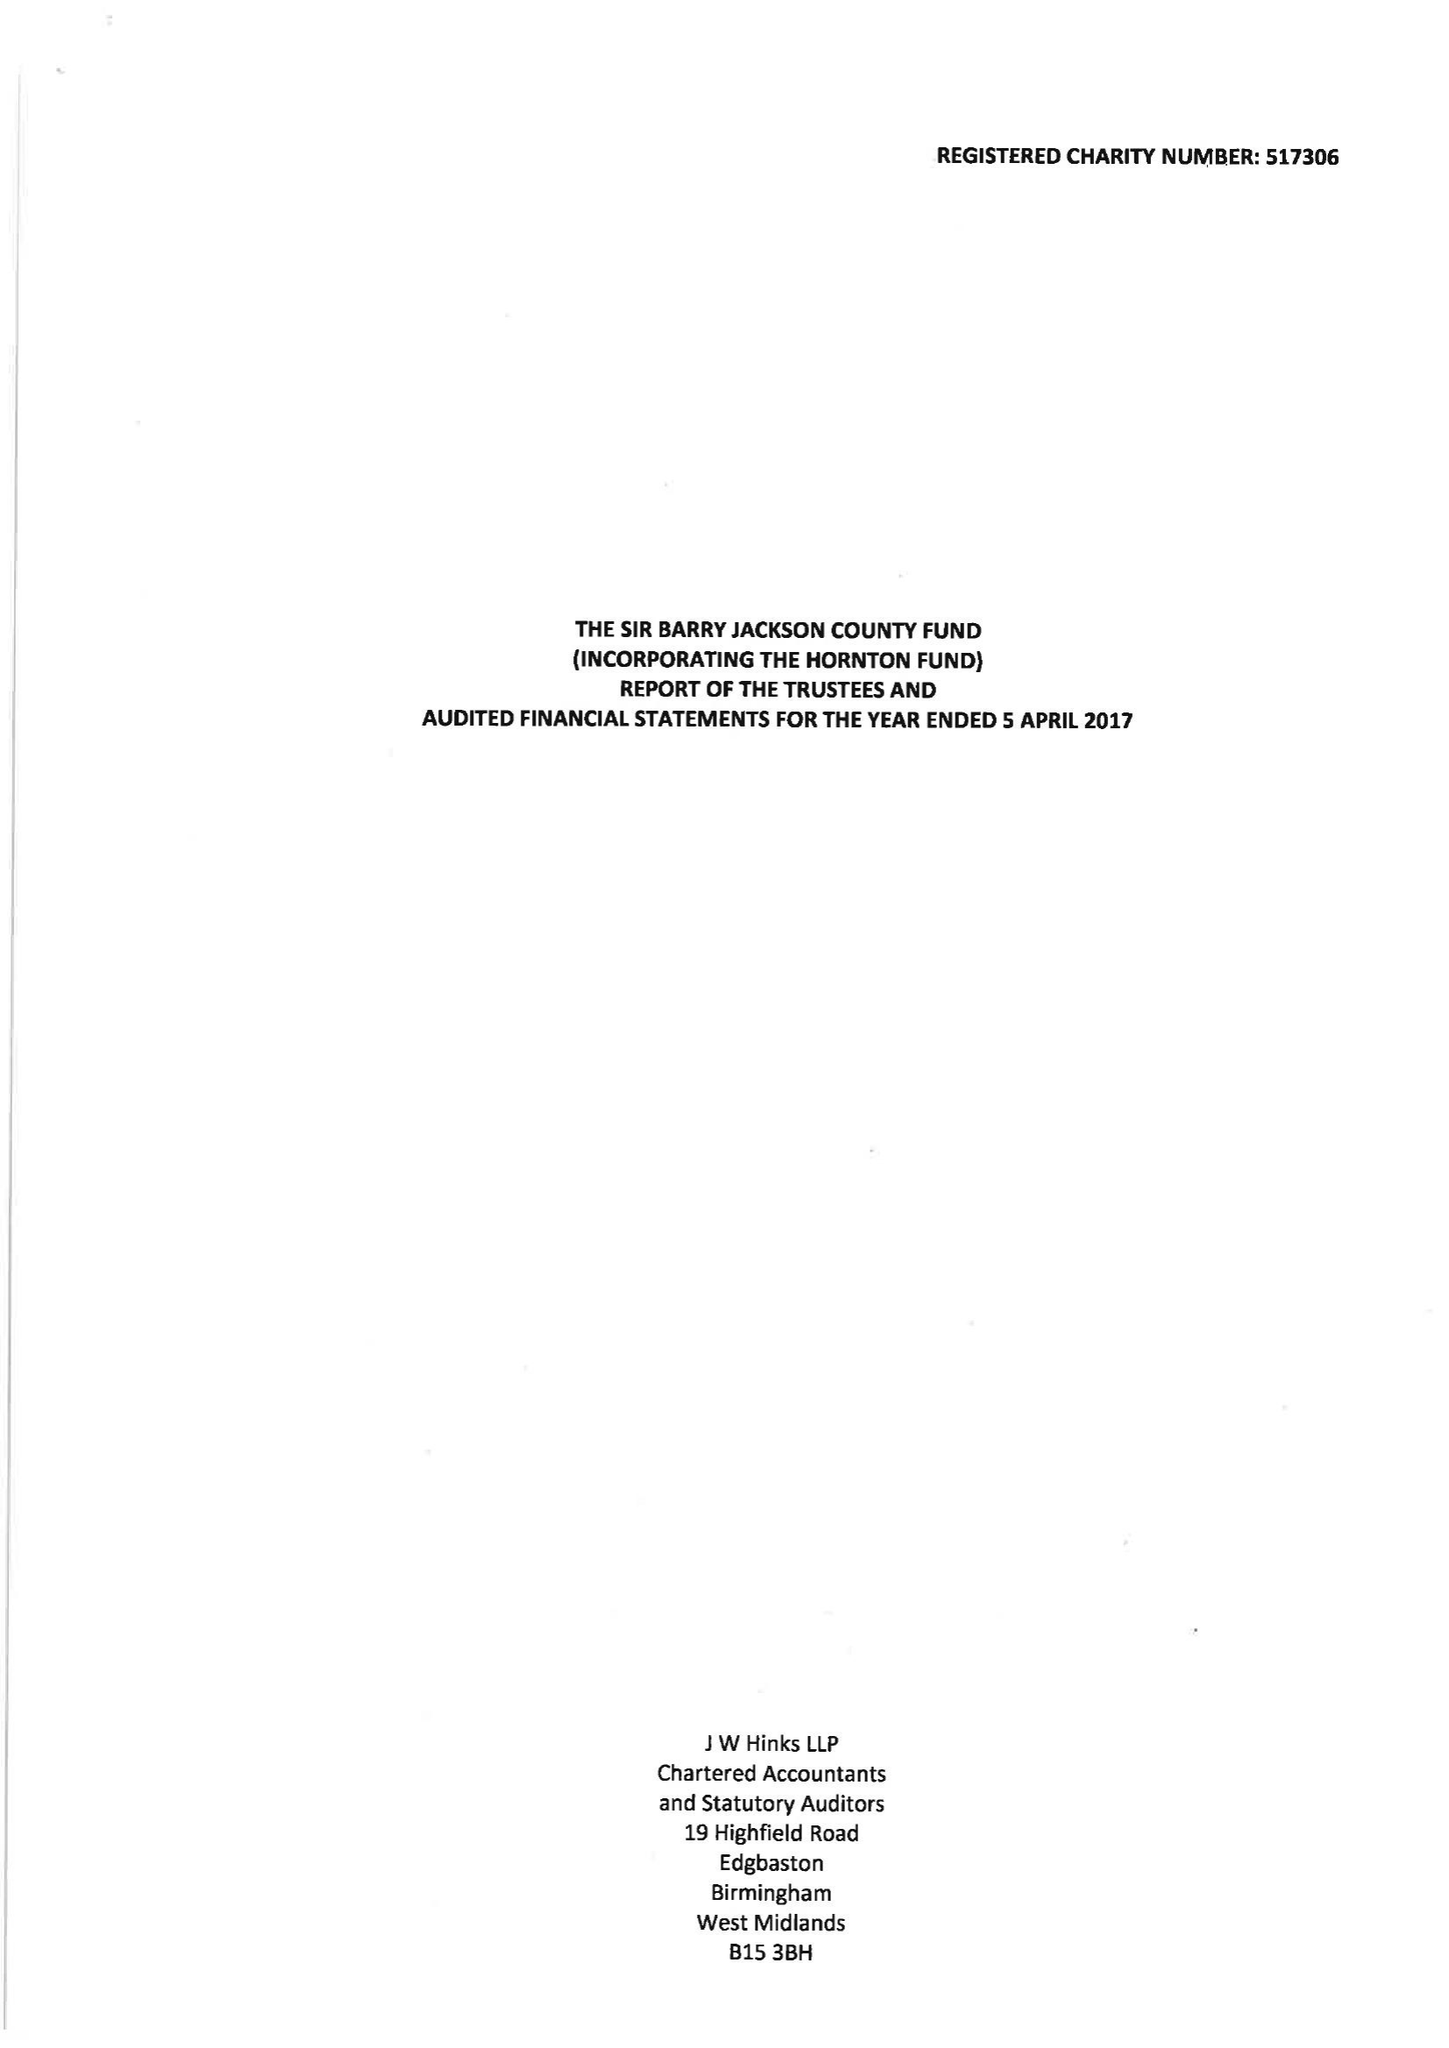What is the value for the address__street_line?
Answer the question using a single word or phrase. BROAD STREET 